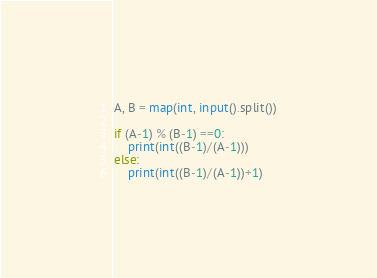Convert code to text. <code><loc_0><loc_0><loc_500><loc_500><_Python_>A, B = map(int, input().split())

if (A-1) % (B-1) ==0:
	print(int((B-1)/(A-1)))
else:
	print(int((B-1)/(A-1))+1)</code> 